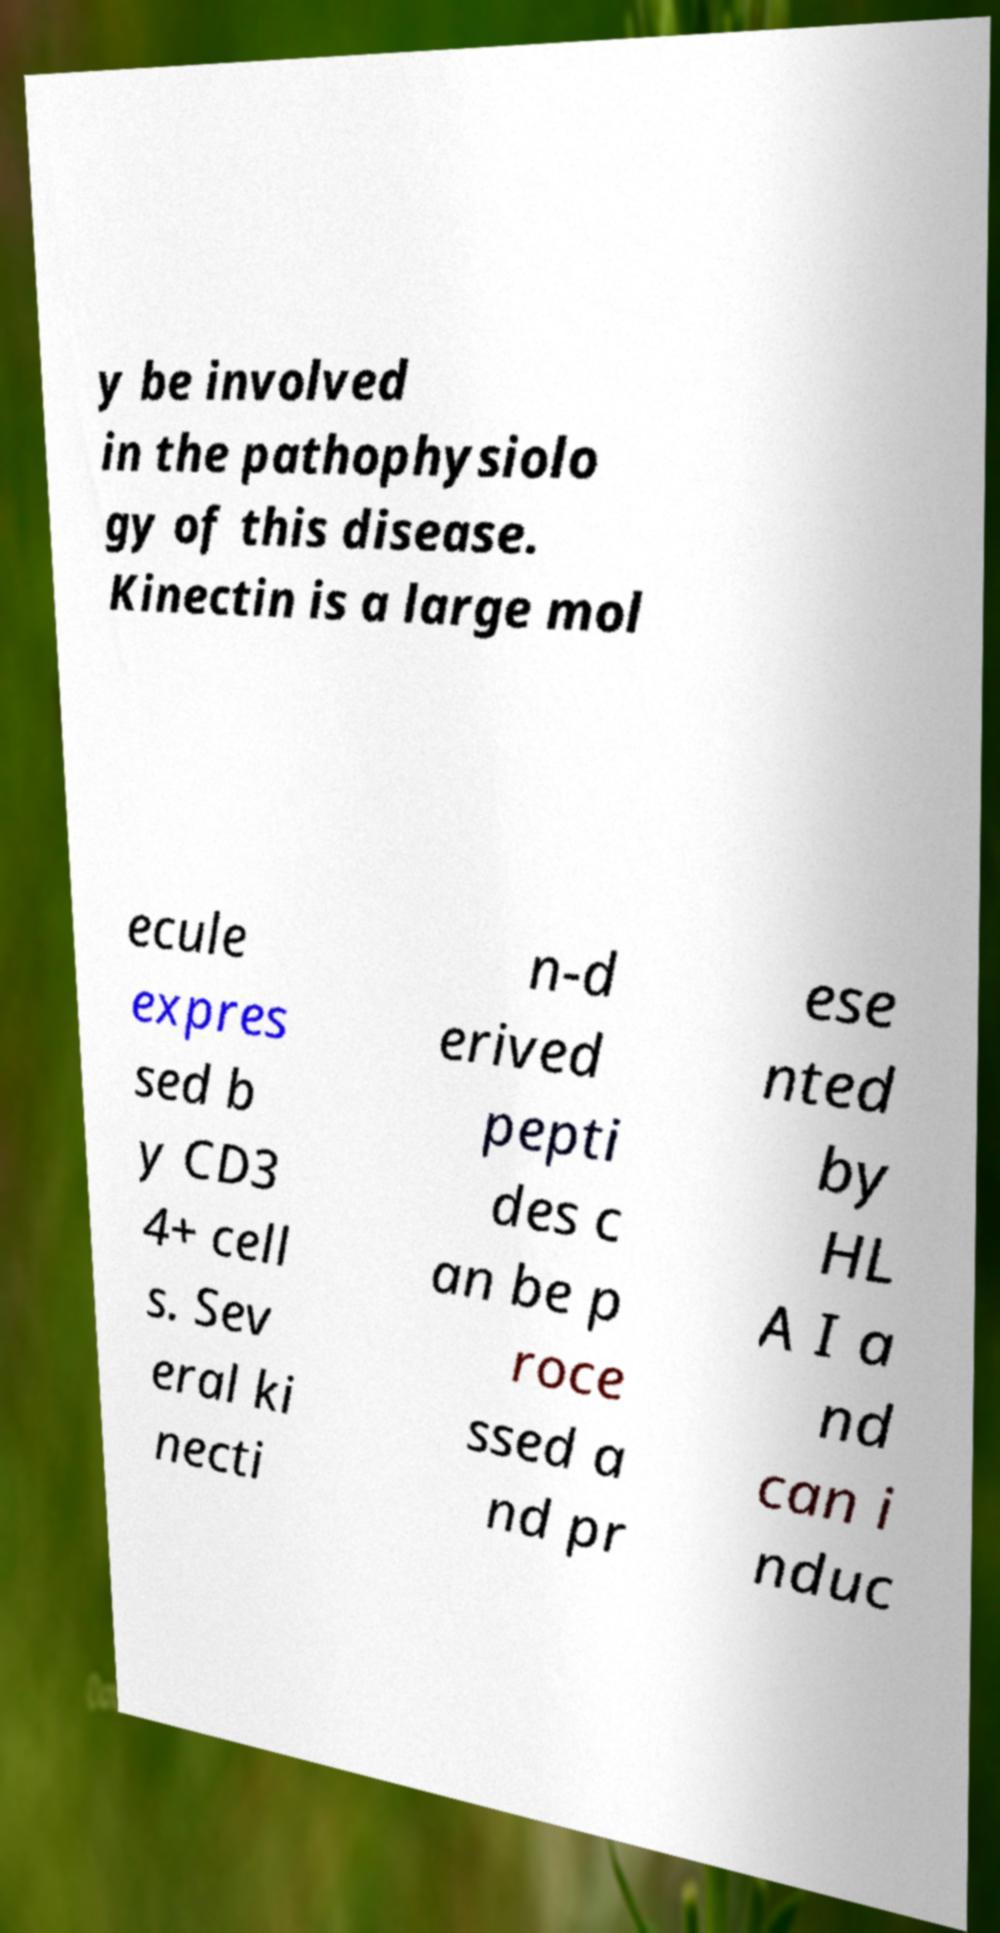I need the written content from this picture converted into text. Can you do that? y be involved in the pathophysiolo gy of this disease. Kinectin is a large mol ecule expres sed b y CD3 4+ cell s. Sev eral ki necti n-d erived pepti des c an be p roce ssed a nd pr ese nted by HL A I a nd can i nduc 